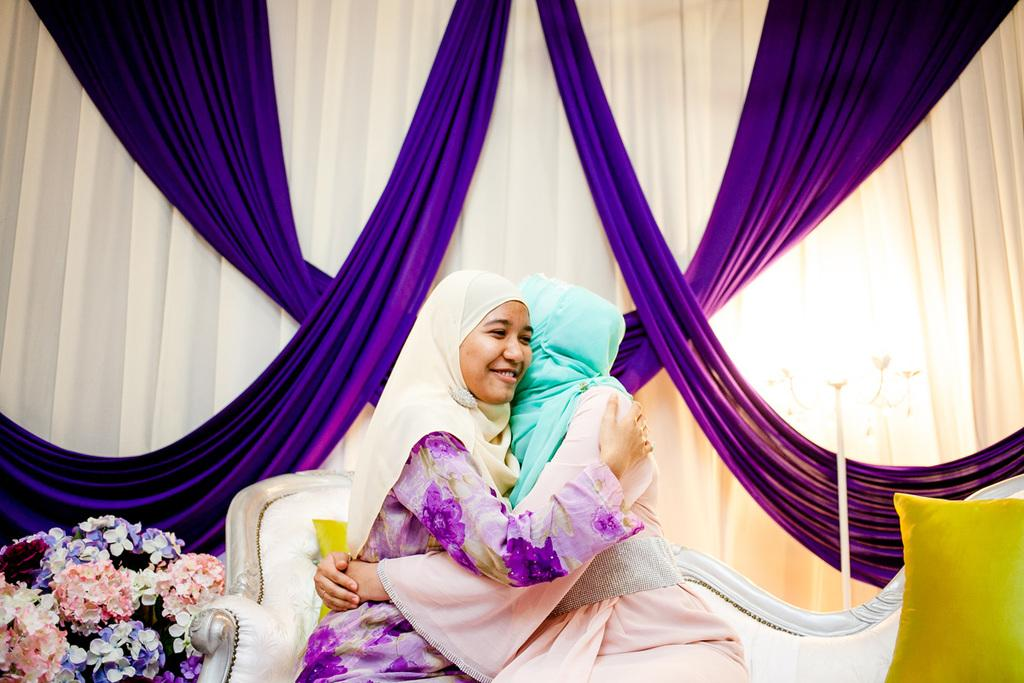How many people are in the image? There are two girls in the image. What are the girls doing in the image? The girls are hugging each other. Where are the girls sitting in the image? The girls are sitting on a sofa. What can be seen beside the girls in the image? There is a flower pot beside the girls. What can be seen in the background of the image? There are decorative curtains in the background. What color is the paint on the father's shirt in the image? There is no father present in the image, and therefore no shirt or paint to describe. 